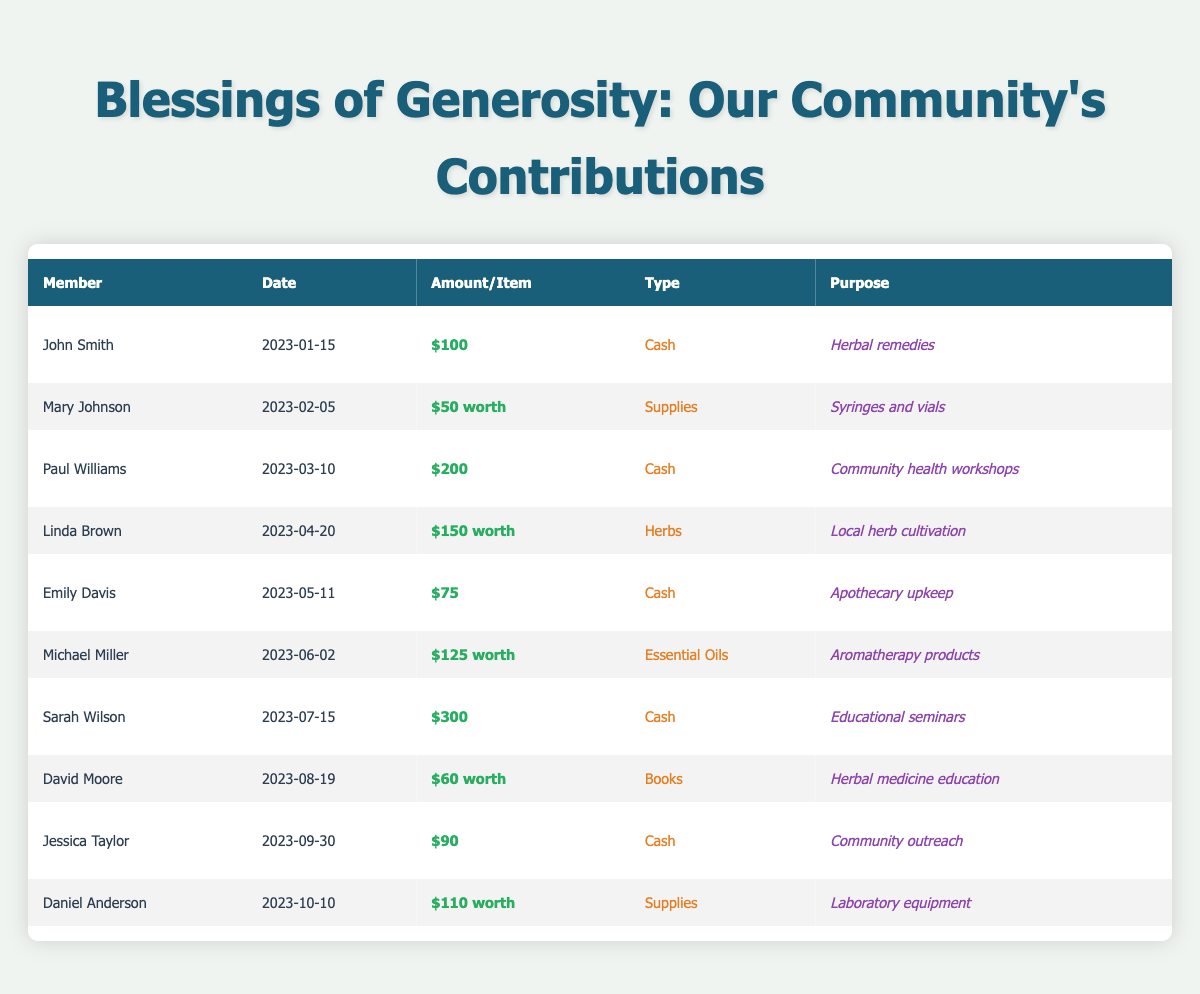What is the total amount donated by Sarah Wilson? Sarah Wilson's donation is listed in the table as $300.
Answer: $300 Who contributed supplies for laboratory equipment? The table shows that Daniel Anderson contributed supplies worth $110 for laboratory equipment.
Answer: Daniel Anderson What was the donation purpose of Linda Brown? According to the table, Linda Brown's donation purpose was local herb cultivation.
Answer: Local herb cultivation What is the average donation amount from cash donations? The cash donations listed are $100, $200, $75, $300, and $90, which sum to $765. Dividing this by the 5 cash donations gives an average of $153.
Answer: $153 How many members donated more than $100? The table shows that John Smith, Paul Williams, Sarah Wilson, and Michael Miller donated amounts greater than $100. This gives a total of 4 members.
Answer: 4 Did any member donate books as part of their contribution? Yes, the table indicates that David Moore made a donation of books worth $60 for herbal medicine education.
Answer: Yes What is the total value of donations made by Emily Davis and Jessica Taylor? Emily Davis donated $75 and Jessica Taylor donated $90. Adding these amounts together gives a total of $165.
Answer: $165 Which member had the highest single donation amount? By reviewing the amounts in the table, Sarah Wilson's donation of $300 is the highest amount listed.
Answer: Sarah Wilson What type of donation did Michael Miller make? The table indicates that Michael Miller donated essential oils.
Answer: Essential oils If we categorize donations by their type, how many are from cash? There are a total of 5 cash donations listed in the table.
Answer: 5 What was the earliest donation date recorded in the table? The earliest date found in the table is January 15, 2023, from John Smith.
Answer: January 15, 2023 